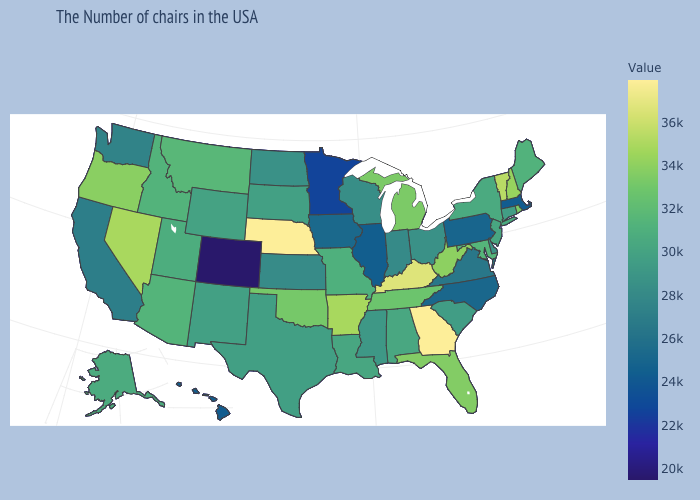Does Connecticut have a lower value than North Carolina?
Short answer required. No. Does Utah have a higher value than Ohio?
Short answer required. Yes. Does Nebraska have the highest value in the USA?
Answer briefly. Yes. Which states have the highest value in the USA?
Concise answer only. Georgia, Nebraska. Among the states that border Montana , which have the highest value?
Write a very short answer. Idaho. Does New York have a lower value than Florida?
Concise answer only. Yes. Among the states that border North Dakota , does Minnesota have the highest value?
Write a very short answer. No. Does Georgia have the highest value in the USA?
Short answer required. Yes. Does Montana have the highest value in the West?
Concise answer only. No. 